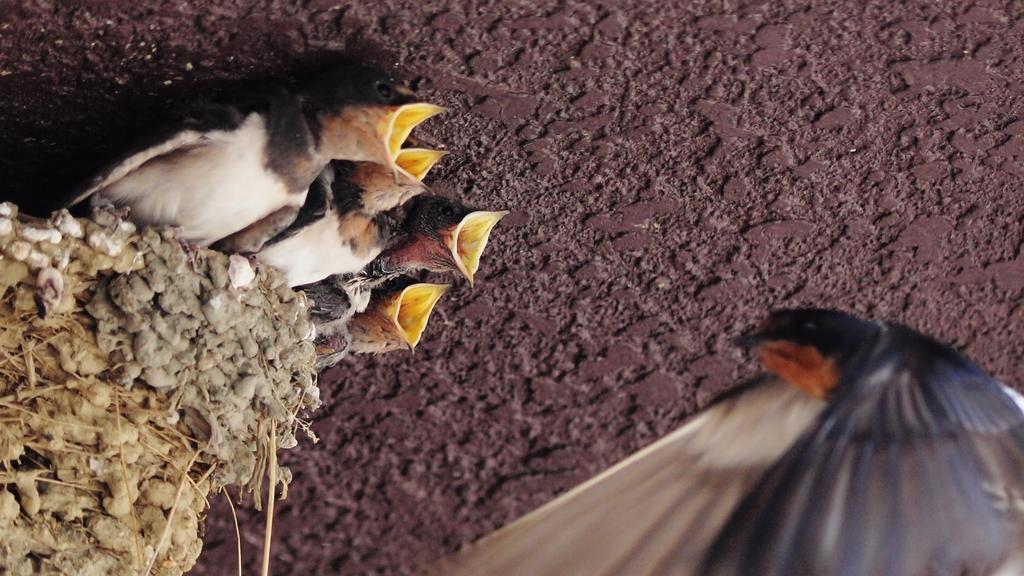Could you give a brief overview of what you see in this image? In the foreground of this picture we can see a bird like thing. On the left we can see the nestlings opening their mouth and standing on the nest. In the background there is an object which seems to be the trunk of a tree. 